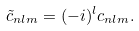Convert formula to latex. <formula><loc_0><loc_0><loc_500><loc_500>\tilde { c } _ { n l m } = ( - i ) ^ { l } c _ { n l m } .</formula> 